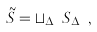Convert formula to latex. <formula><loc_0><loc_0><loc_500><loc_500>\tilde { S } = \sqcup _ { \Delta _ { A } } S _ { \Delta _ { A } } ,</formula> 